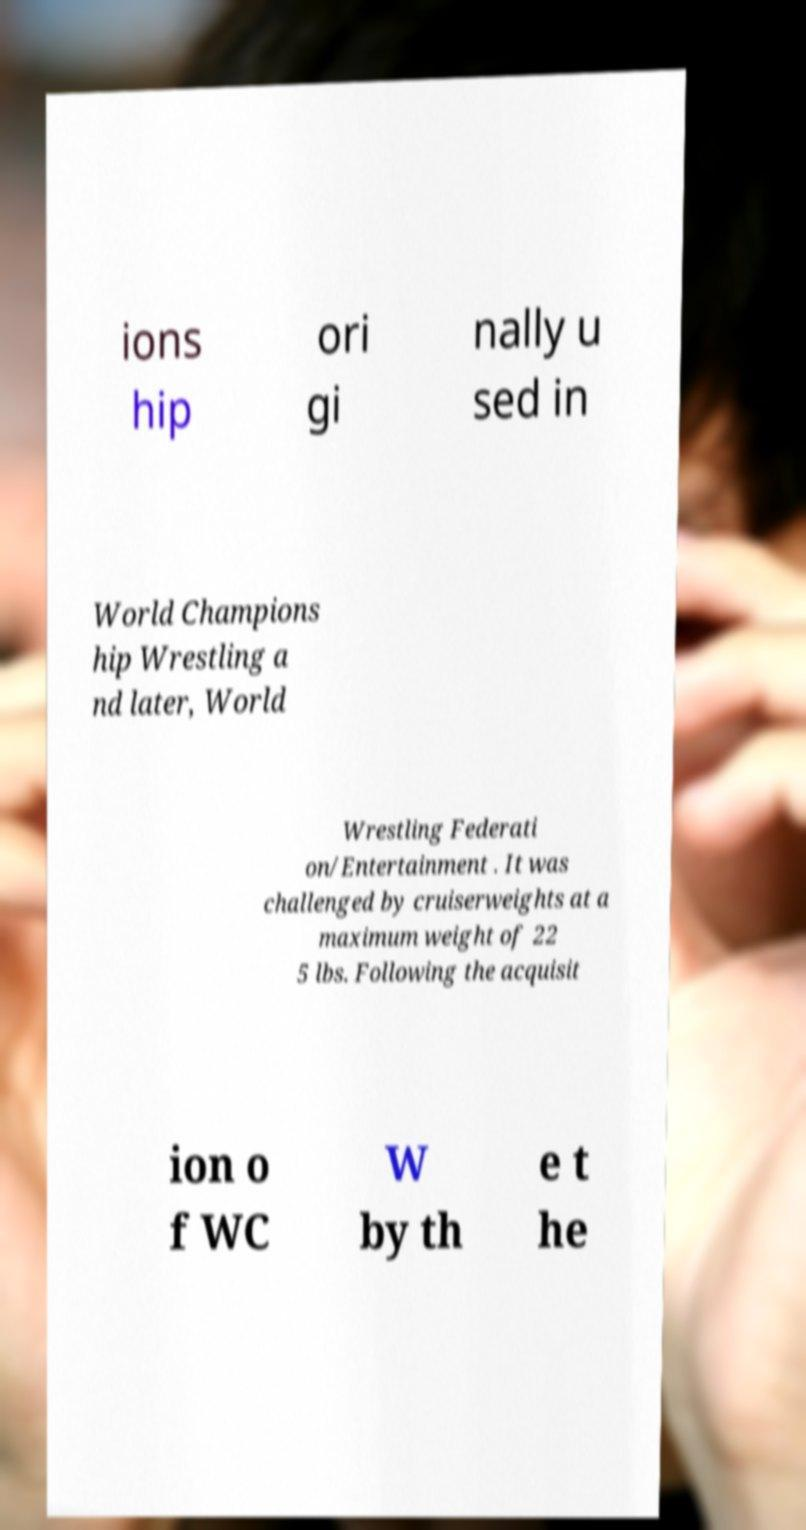Could you assist in decoding the text presented in this image and type it out clearly? ions hip ori gi nally u sed in World Champions hip Wrestling a nd later, World Wrestling Federati on/Entertainment . It was challenged by cruiserweights at a maximum weight of 22 5 lbs. Following the acquisit ion o f WC W by th e t he 